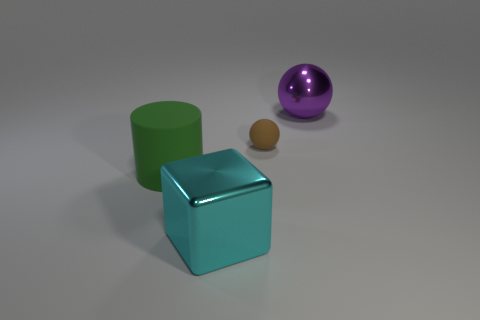Add 3 small gray objects. How many objects exist? 7 Subtract 0 blue cylinders. How many objects are left? 4 Subtract all cubes. How many objects are left? 3 Subtract all brown balls. Subtract all green blocks. How many balls are left? 1 Subtract all small gray shiny balls. Subtract all tiny brown rubber balls. How many objects are left? 3 Add 4 large purple metal balls. How many large purple metal balls are left? 5 Add 1 small rubber spheres. How many small rubber spheres exist? 2 